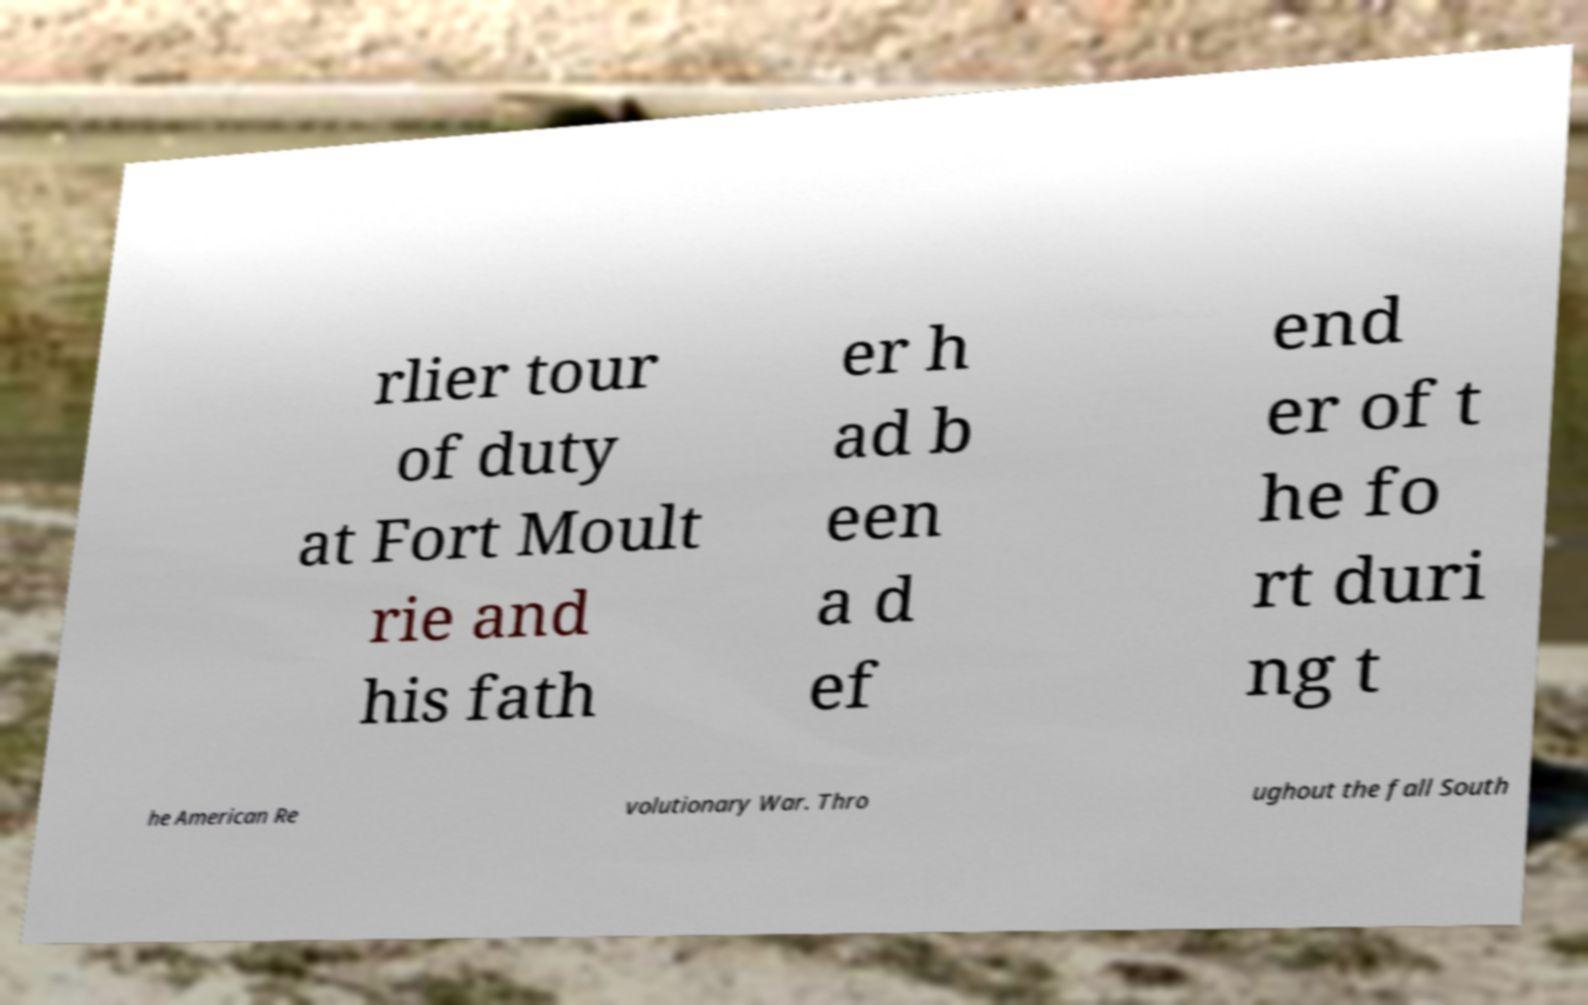What messages or text are displayed in this image? I need them in a readable, typed format. rlier tour of duty at Fort Moult rie and his fath er h ad b een a d ef end er of t he fo rt duri ng t he American Re volutionary War. Thro ughout the fall South 